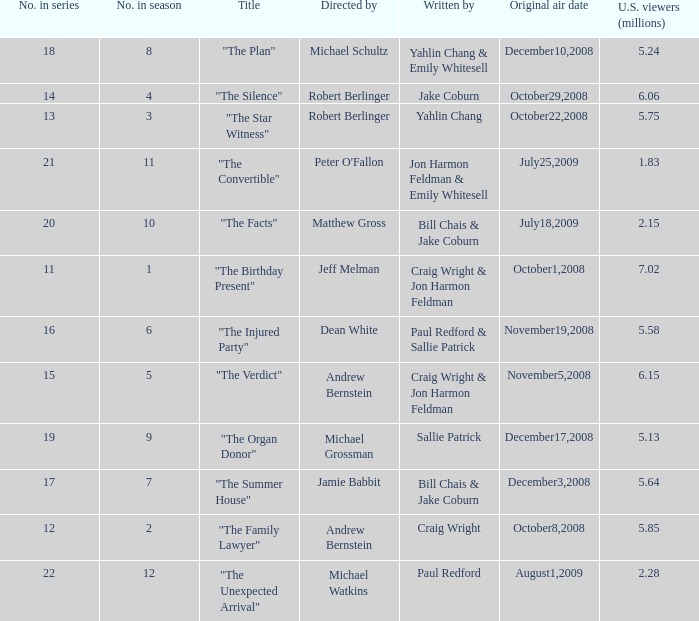When did the jeff melman-directed episode have its initial airing? October1,2008. 